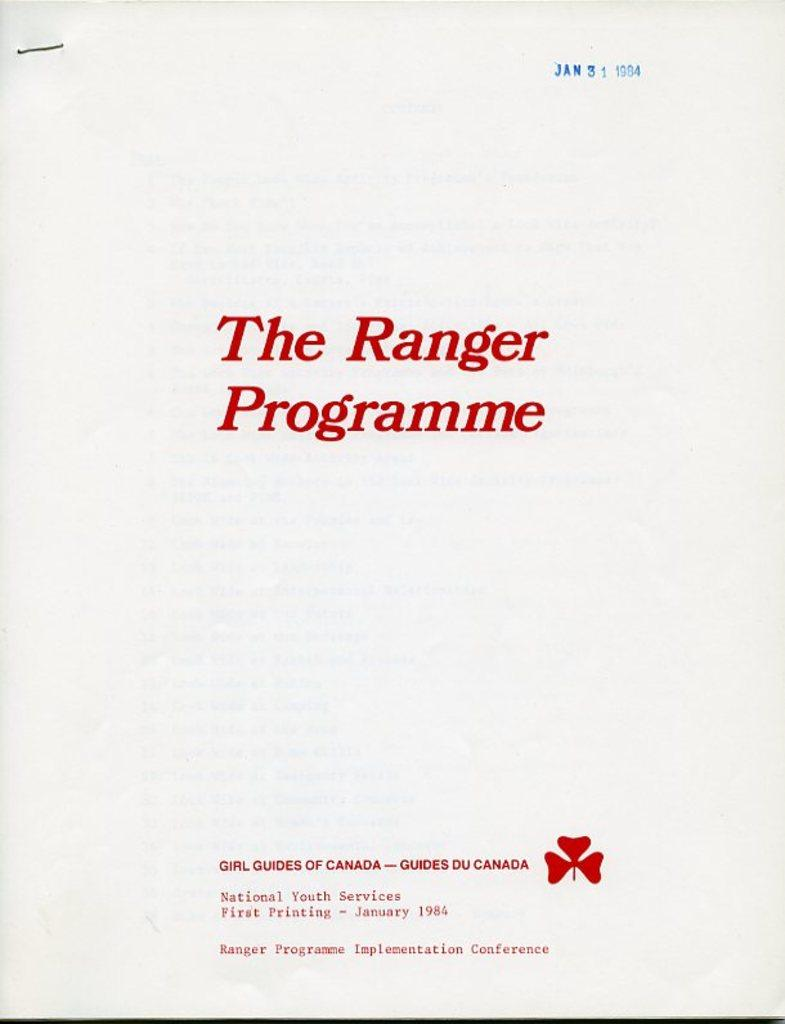<image>
Offer a succinct explanation of the picture presented. a booklet titled the ranger programme dated from January 31st 1984. 